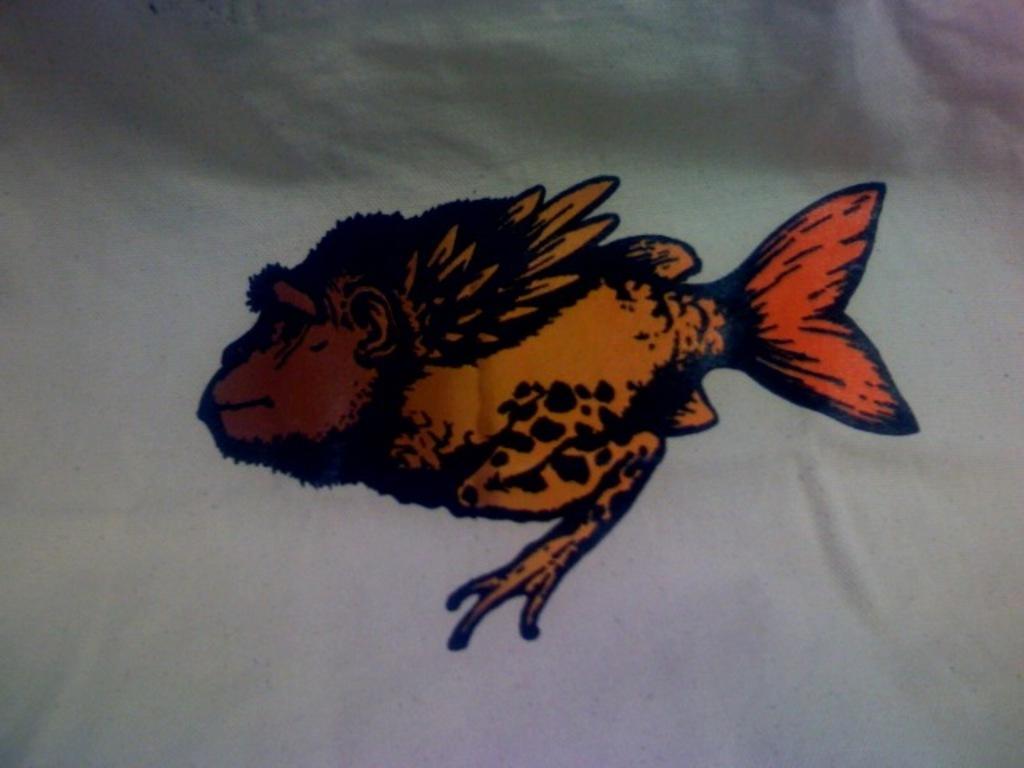Can you describe this image briefly? In the middle of this image, there is a painting of a fish on a cloth. And the background is white in color. 